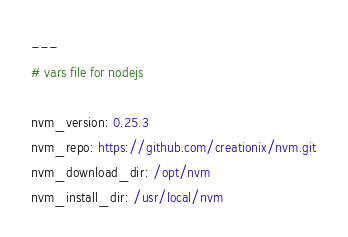<code> <loc_0><loc_0><loc_500><loc_500><_YAML_>---
# vars file for nodejs

nvm_version: 0.25.3
nvm_repo: https://github.com/creationix/nvm.git
nvm_download_dir: /opt/nvm
nvm_install_dir: /usr/local/nvm
</code> 